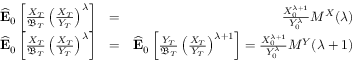Convert formula to latex. <formula><loc_0><loc_0><loc_500><loc_500>\begin{array} { r l r } { \widehat { E } _ { 0 } \left [ \frac { X _ { T } } { \mathfrak { B } _ { T } } \left ( \frac { X _ { T } } { Y _ { T } } \right ) ^ { \lambda } \right ] } & { = } & { \frac { X _ { 0 } ^ { \lambda + 1 } } { Y _ { 0 } ^ { \lambda } } M ^ { X } ( \lambda ) } \\ { \widehat { E } _ { 0 } \left [ \frac { X _ { T } } { \mathfrak { B } _ { T } } \left ( \frac { X _ { T } } { Y _ { T } } \right ) ^ { \lambda } \right ] } & { = } & { \widehat { E } _ { 0 } \left [ \frac { Y _ { T } } { \mathfrak { B } _ { T } } \left ( \frac { X _ { T } } { Y _ { T } } \right ) ^ { \lambda + 1 } \right ] = \frac { X _ { 0 } ^ { \lambda + 1 } } { Y _ { 0 } ^ { \lambda } } M ^ { Y } ( \lambda + 1 ) } \end{array}</formula> 